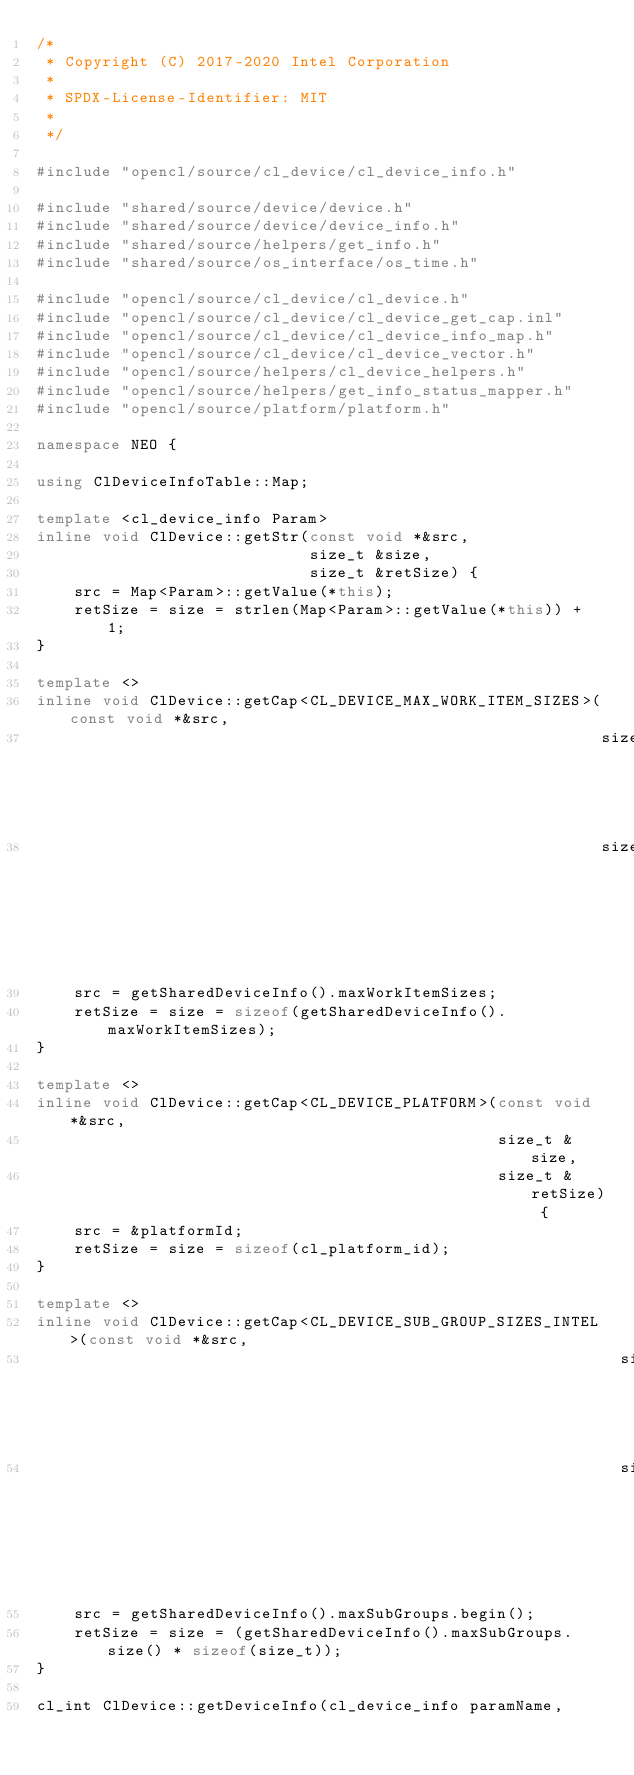<code> <loc_0><loc_0><loc_500><loc_500><_C++_>/*
 * Copyright (C) 2017-2020 Intel Corporation
 *
 * SPDX-License-Identifier: MIT
 *
 */

#include "opencl/source/cl_device/cl_device_info.h"

#include "shared/source/device/device.h"
#include "shared/source/device/device_info.h"
#include "shared/source/helpers/get_info.h"
#include "shared/source/os_interface/os_time.h"

#include "opencl/source/cl_device/cl_device.h"
#include "opencl/source/cl_device/cl_device_get_cap.inl"
#include "opencl/source/cl_device/cl_device_info_map.h"
#include "opencl/source/cl_device/cl_device_vector.h"
#include "opencl/source/helpers/cl_device_helpers.h"
#include "opencl/source/helpers/get_info_status_mapper.h"
#include "opencl/source/platform/platform.h"

namespace NEO {

using ClDeviceInfoTable::Map;

template <cl_device_info Param>
inline void ClDevice::getStr(const void *&src,
                             size_t &size,
                             size_t &retSize) {
    src = Map<Param>::getValue(*this);
    retSize = size = strlen(Map<Param>::getValue(*this)) + 1;
}

template <>
inline void ClDevice::getCap<CL_DEVICE_MAX_WORK_ITEM_SIZES>(const void *&src,
                                                            size_t &size,
                                                            size_t &retSize) {
    src = getSharedDeviceInfo().maxWorkItemSizes;
    retSize = size = sizeof(getSharedDeviceInfo().maxWorkItemSizes);
}

template <>
inline void ClDevice::getCap<CL_DEVICE_PLATFORM>(const void *&src,
                                                 size_t &size,
                                                 size_t &retSize) {
    src = &platformId;
    retSize = size = sizeof(cl_platform_id);
}

template <>
inline void ClDevice::getCap<CL_DEVICE_SUB_GROUP_SIZES_INTEL>(const void *&src,
                                                              size_t &size,
                                                              size_t &retSize) {
    src = getSharedDeviceInfo().maxSubGroups.begin();
    retSize = size = (getSharedDeviceInfo().maxSubGroups.size() * sizeof(size_t));
}

cl_int ClDevice::getDeviceInfo(cl_device_info paramName,</code> 